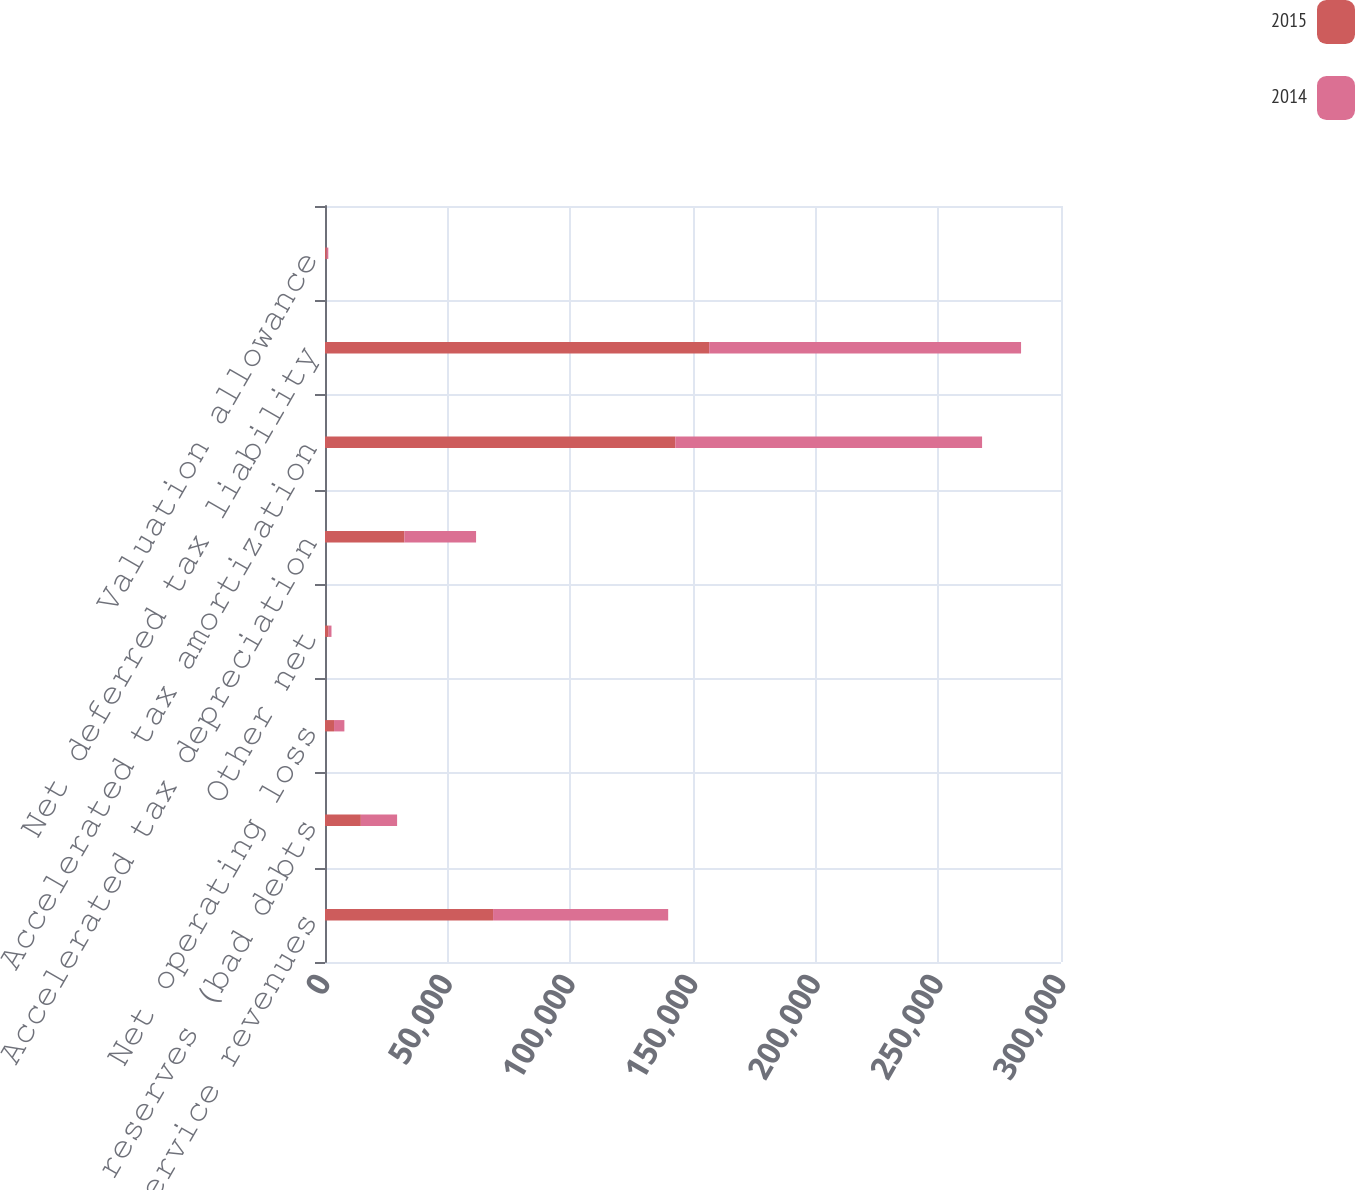Convert chart to OTSL. <chart><loc_0><loc_0><loc_500><loc_500><stacked_bar_chart><ecel><fcel>Contract and service revenues<fcel>Expense reserves (bad debts<fcel>Net operating loss<fcel>Other net<fcel>Accelerated tax depreciation<fcel>Accelerated tax amortization<fcel>Net deferred tax liability<fcel>Valuation allowance<nl><fcel>2015<fcel>68503<fcel>14612<fcel>3682<fcel>1493<fcel>32331<fcel>142776<fcel>156607<fcel>650<nl><fcel>2014<fcel>71383<fcel>14776<fcel>4218<fcel>1148<fcel>29247<fcel>125054<fcel>127114<fcel>700<nl></chart> 